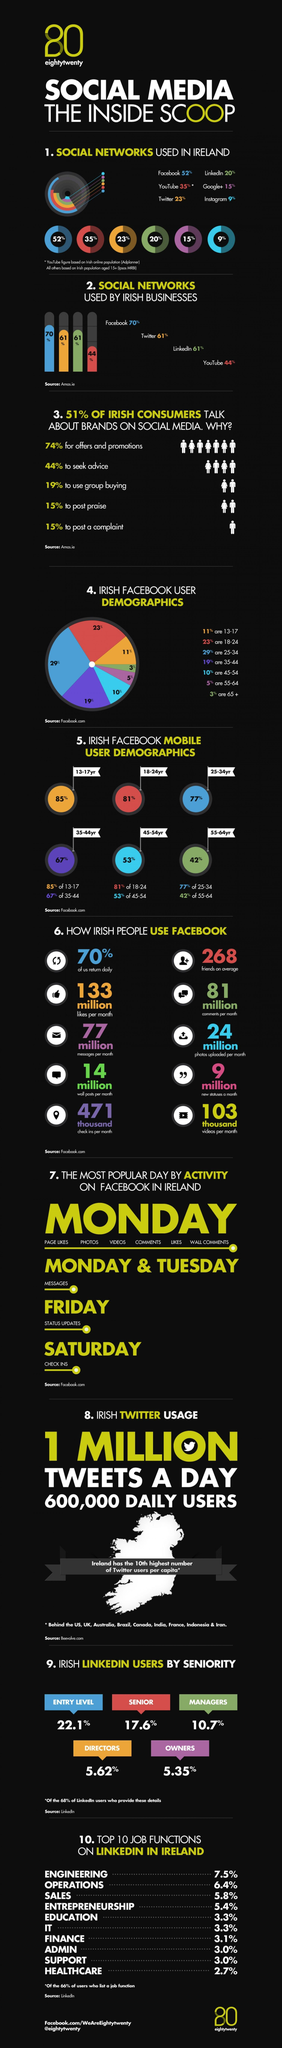What percentage of senior citizens use Facebook?
Answer the question with a short phrase. 3% What percentage of Linkedin users are managers and directors? 16.32% What do the highest percentage of consumers talk about in social media? offers and promotions Which social network is most popular after Facebook in Ireland? YouTube Which is the least popular social media in Ireland? Instagram What percent of people post praise and complaint on social media? 30% Which social network is most preferred by businesses? Facebook What percentage of Facebook users are between the age of 24 and 44? 48% 